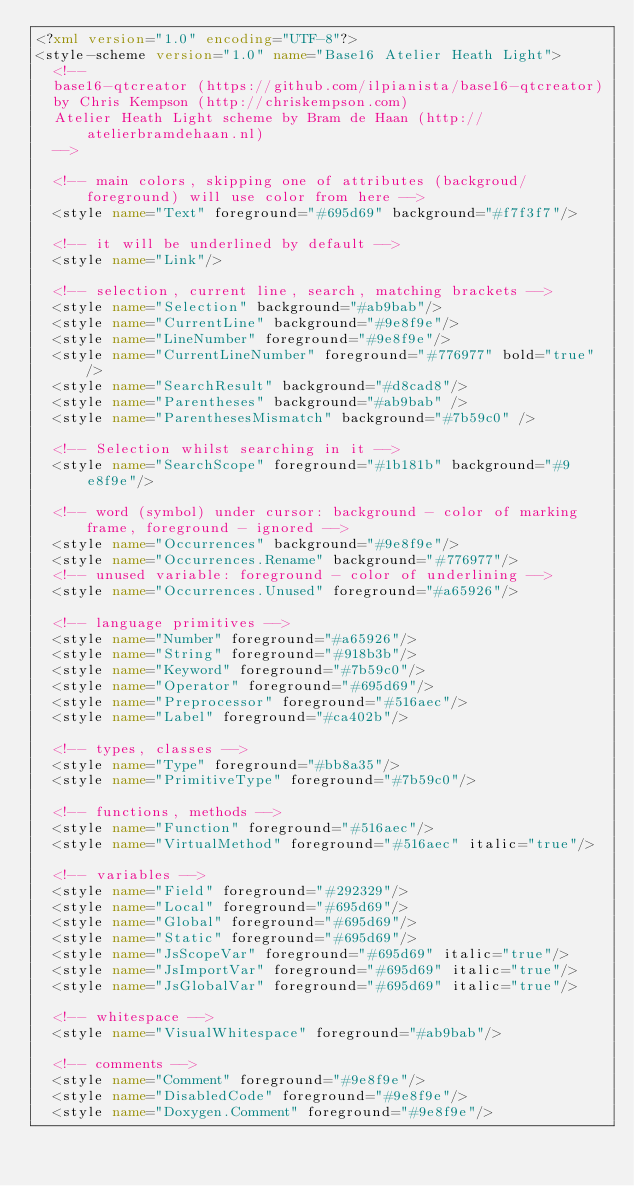<code> <loc_0><loc_0><loc_500><loc_500><_XML_><?xml version="1.0" encoding="UTF-8"?>
<style-scheme version="1.0" name="Base16 Atelier Heath Light">
  <!--
  base16-qtcreator (https://github.com/ilpianista/base16-qtcreator)
  by Chris Kempson (http://chriskempson.com)
  Atelier Heath Light scheme by Bram de Haan (http://atelierbramdehaan.nl)
  -->

  <!-- main colors, skipping one of attributes (backgroud/foreground) will use color from here -->
  <style name="Text" foreground="#695d69" background="#f7f3f7"/>

  <!-- it will be underlined by default -->
  <style name="Link"/>

  <!-- selection, current line, search, matching brackets -->
  <style name="Selection" background="#ab9bab"/>
  <style name="CurrentLine" background="#9e8f9e"/>
  <style name="LineNumber" foreground="#9e8f9e"/>
  <style name="CurrentLineNumber" foreground="#776977" bold="true"/>
  <style name="SearchResult" background="#d8cad8"/>
  <style name="Parentheses" background="#ab9bab" />
  <style name="ParenthesesMismatch" background="#7b59c0" />

  <!-- Selection whilst searching in it -->
  <style name="SearchScope" foreground="#1b181b" background="#9e8f9e"/>

  <!-- word (symbol) under cursor: background - color of marking frame, foreground - ignored -->
  <style name="Occurrences" background="#9e8f9e"/>
  <style name="Occurrences.Rename" background="#776977"/>
  <!-- unused variable: foreground - color of underlining -->
  <style name="Occurrences.Unused" foreground="#a65926"/>

  <!-- language primitives -->
  <style name="Number" foreground="#a65926"/>
  <style name="String" foreground="#918b3b"/>
  <style name="Keyword" foreground="#7b59c0"/>
  <style name="Operator" foreground="#695d69"/>
  <style name="Preprocessor" foreground="#516aec"/>
  <style name="Label" foreground="#ca402b"/>

  <!-- types, classes -->
  <style name="Type" foreground="#bb8a35"/>
  <style name="PrimitiveType" foreground="#7b59c0"/>

  <!-- functions, methods -->
  <style name="Function" foreground="#516aec"/>
  <style name="VirtualMethod" foreground="#516aec" italic="true"/>

  <!-- variables -->
  <style name="Field" foreground="#292329"/>
  <style name="Local" foreground="#695d69"/>
  <style name="Global" foreground="#695d69"/>
  <style name="Static" foreground="#695d69"/>
  <style name="JsScopeVar" foreground="#695d69" italic="true"/>
  <style name="JsImportVar" foreground="#695d69" italic="true"/>
  <style name="JsGlobalVar" foreground="#695d69" italic="true"/>

  <!-- whitespace -->
  <style name="VisualWhitespace" foreground="#ab9bab"/>

  <!-- comments -->
  <style name="Comment" foreground="#9e8f9e"/>
  <style name="DisabledCode" foreground="#9e8f9e"/>
  <style name="Doxygen.Comment" foreground="#9e8f9e"/></code> 